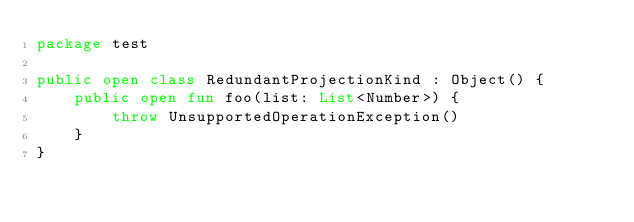Convert code to text. <code><loc_0><loc_0><loc_500><loc_500><_Kotlin_>package test

public open class RedundantProjectionKind : Object() {
    public open fun foo(list: List<Number>) {
        throw UnsupportedOperationException()
    }
}
</code> 